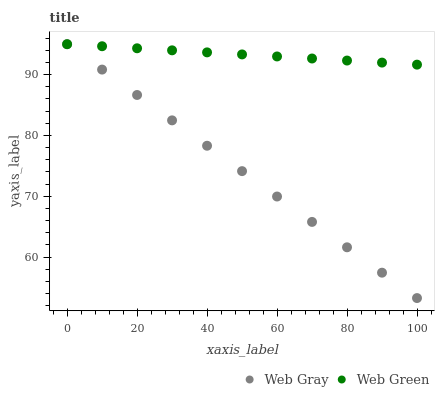Does Web Gray have the minimum area under the curve?
Answer yes or no. Yes. Does Web Green have the maximum area under the curve?
Answer yes or no. Yes. Does Web Green have the minimum area under the curve?
Answer yes or no. No. Is Web Green the smoothest?
Answer yes or no. Yes. Is Web Gray the roughest?
Answer yes or no. Yes. Is Web Green the roughest?
Answer yes or no. No. Does Web Gray have the lowest value?
Answer yes or no. Yes. Does Web Green have the lowest value?
Answer yes or no. No. Does Web Green have the highest value?
Answer yes or no. Yes. Does Web Gray intersect Web Green?
Answer yes or no. Yes. Is Web Gray less than Web Green?
Answer yes or no. No. Is Web Gray greater than Web Green?
Answer yes or no. No. 